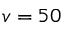<formula> <loc_0><loc_0><loc_500><loc_500>v = 5 0</formula> 